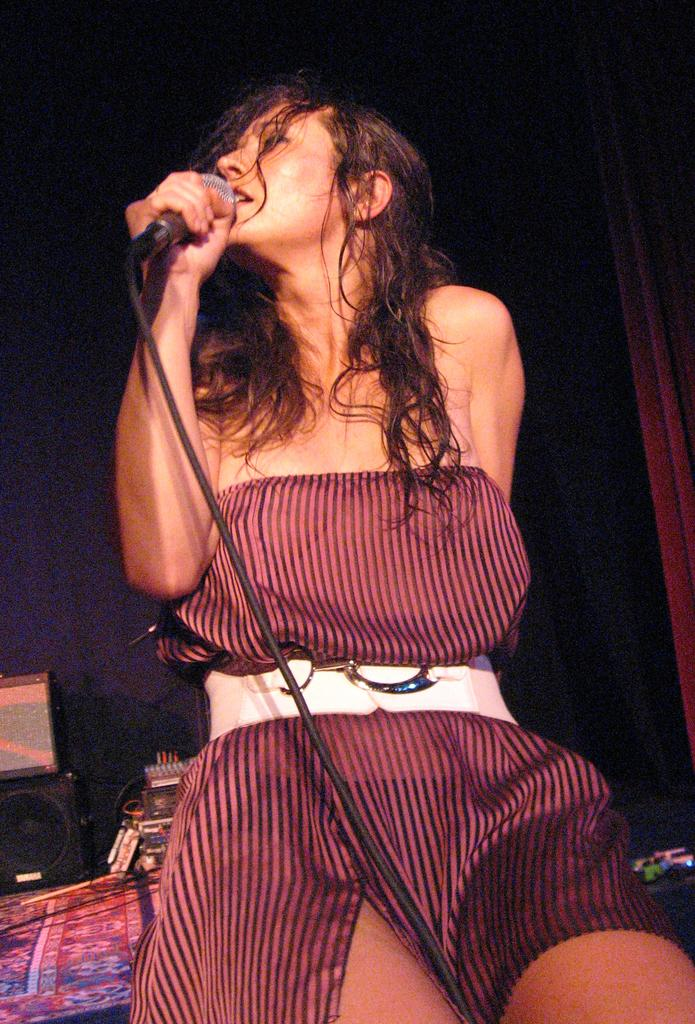Who is the main subject in the image? There is a woman in the image. What is the woman holding in her hand? The woman is holding a mic with a wire. What can be seen in the bottom left corner of the image? There are objects in the bottom left of the image. How would you describe the lighting in the image? The background of the image is dark. How many fingers does the woman have on her left hand in the image? The image does not show the woman's fingers, so it cannot be determined how many fingers she has on her left hand. What type of quartz can be seen in the image? There is no quartz present in the image. 